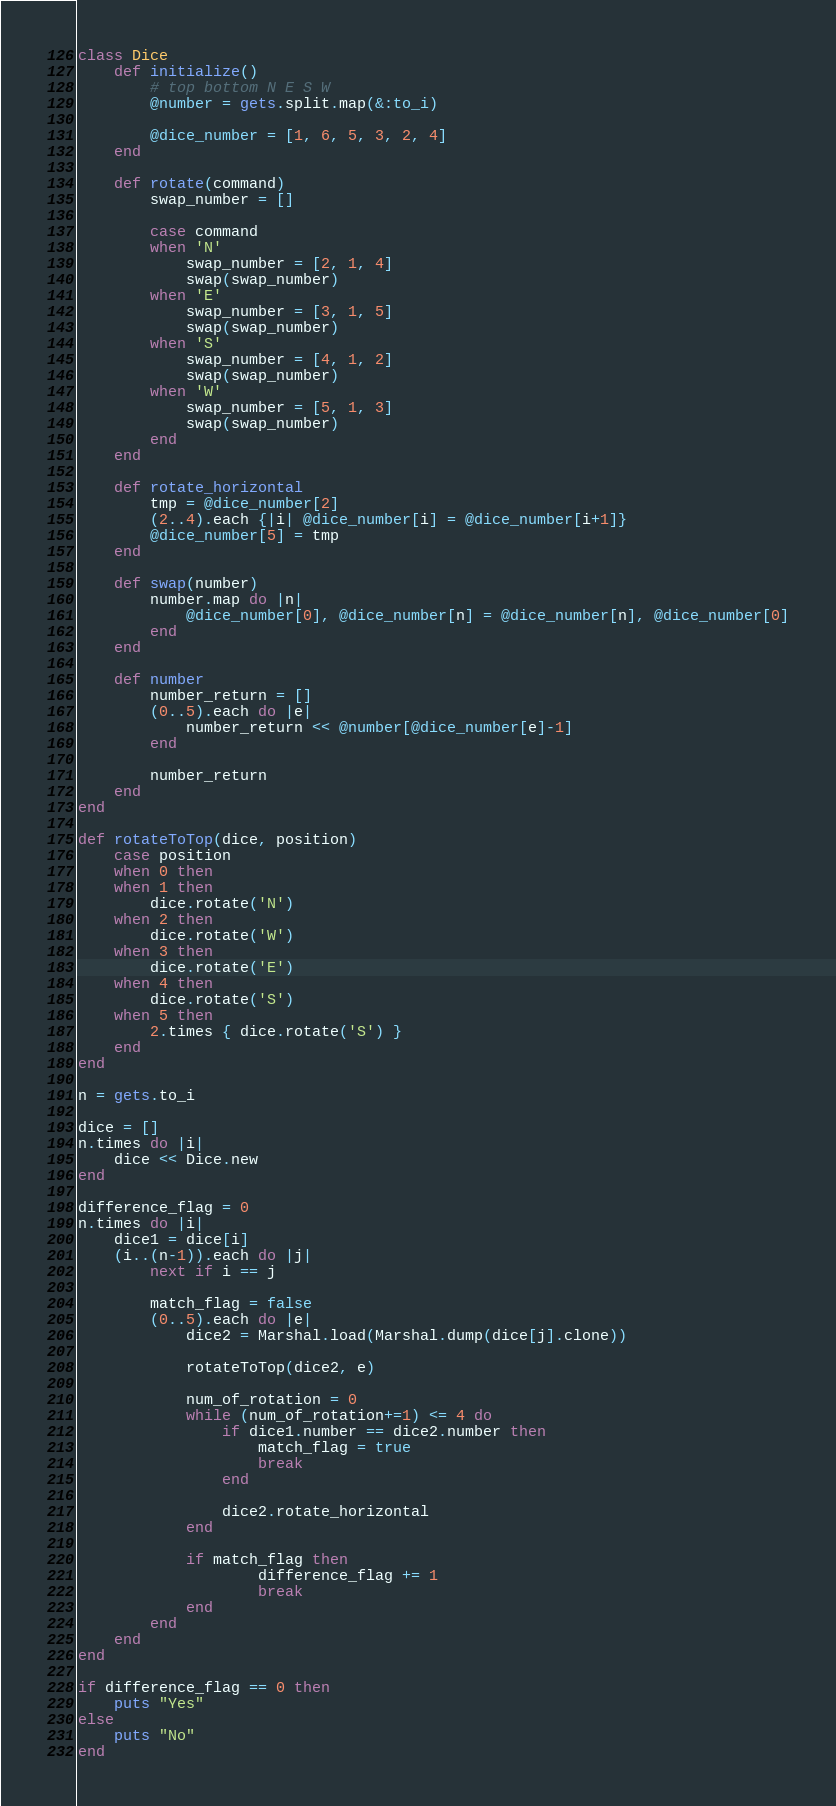Convert code to text. <code><loc_0><loc_0><loc_500><loc_500><_Ruby_>class Dice
	def initialize()
		# top bottom N E S W
		@number = gets.split.map(&:to_i)

		@dice_number = [1, 6, 5, 3, 2, 4]
	end

	def rotate(command)
		swap_number = []

		case command
		when 'N'
			swap_number = [2, 1, 4]
			swap(swap_number)
		when 'E'
			swap_number = [3, 1, 5]
			swap(swap_number)
		when 'S'
			swap_number = [4, 1, 2]
			swap(swap_number)
		when 'W'
			swap_number = [5, 1, 3]
			swap(swap_number)
		end
	end

	def rotate_horizontal
		tmp = @dice_number[2]
		(2..4).each {|i| @dice_number[i] = @dice_number[i+1]}
		@dice_number[5] = tmp
	end

	def swap(number)
		number.map do |n|
			@dice_number[0], @dice_number[n] = @dice_number[n], @dice_number[0]
		end
	end

	def number
		number_return = []
		(0..5).each do |e|
			number_return << @number[@dice_number[e]-1]
		end
		
		number_return
	end
end

def rotateToTop(dice, position)
	case position
	when 0 then
	when 1 then
		dice.rotate('N')
	when 2 then
		dice.rotate('W')
	when 3 then
		dice.rotate('E')
	when 4 then
		dice.rotate('S')
	when 5 then
		2.times { dice.rotate('S') }
	end
end

n = gets.to_i

dice = []
n.times do |i|
	dice << Dice.new
end

difference_flag = 0
n.times do |i|
	dice1 = dice[i]
	(i..(n-1)).each do |j|
		next if i == j

		match_flag = false
		(0..5).each do |e|
			dice2 = Marshal.load(Marshal.dump(dice[j].clone))

			rotateToTop(dice2, e)

			num_of_rotation = 0
			while (num_of_rotation+=1) <= 4 do
				if dice1.number == dice2.number then
					match_flag = true
					break
				end
		
				dice2.rotate_horizontal
			end
	
			if match_flag then
					difference_flag += 1
					break
			end
		end
	end
end

if difference_flag == 0 then
	puts "Yes"
else
	puts "No"
end</code> 